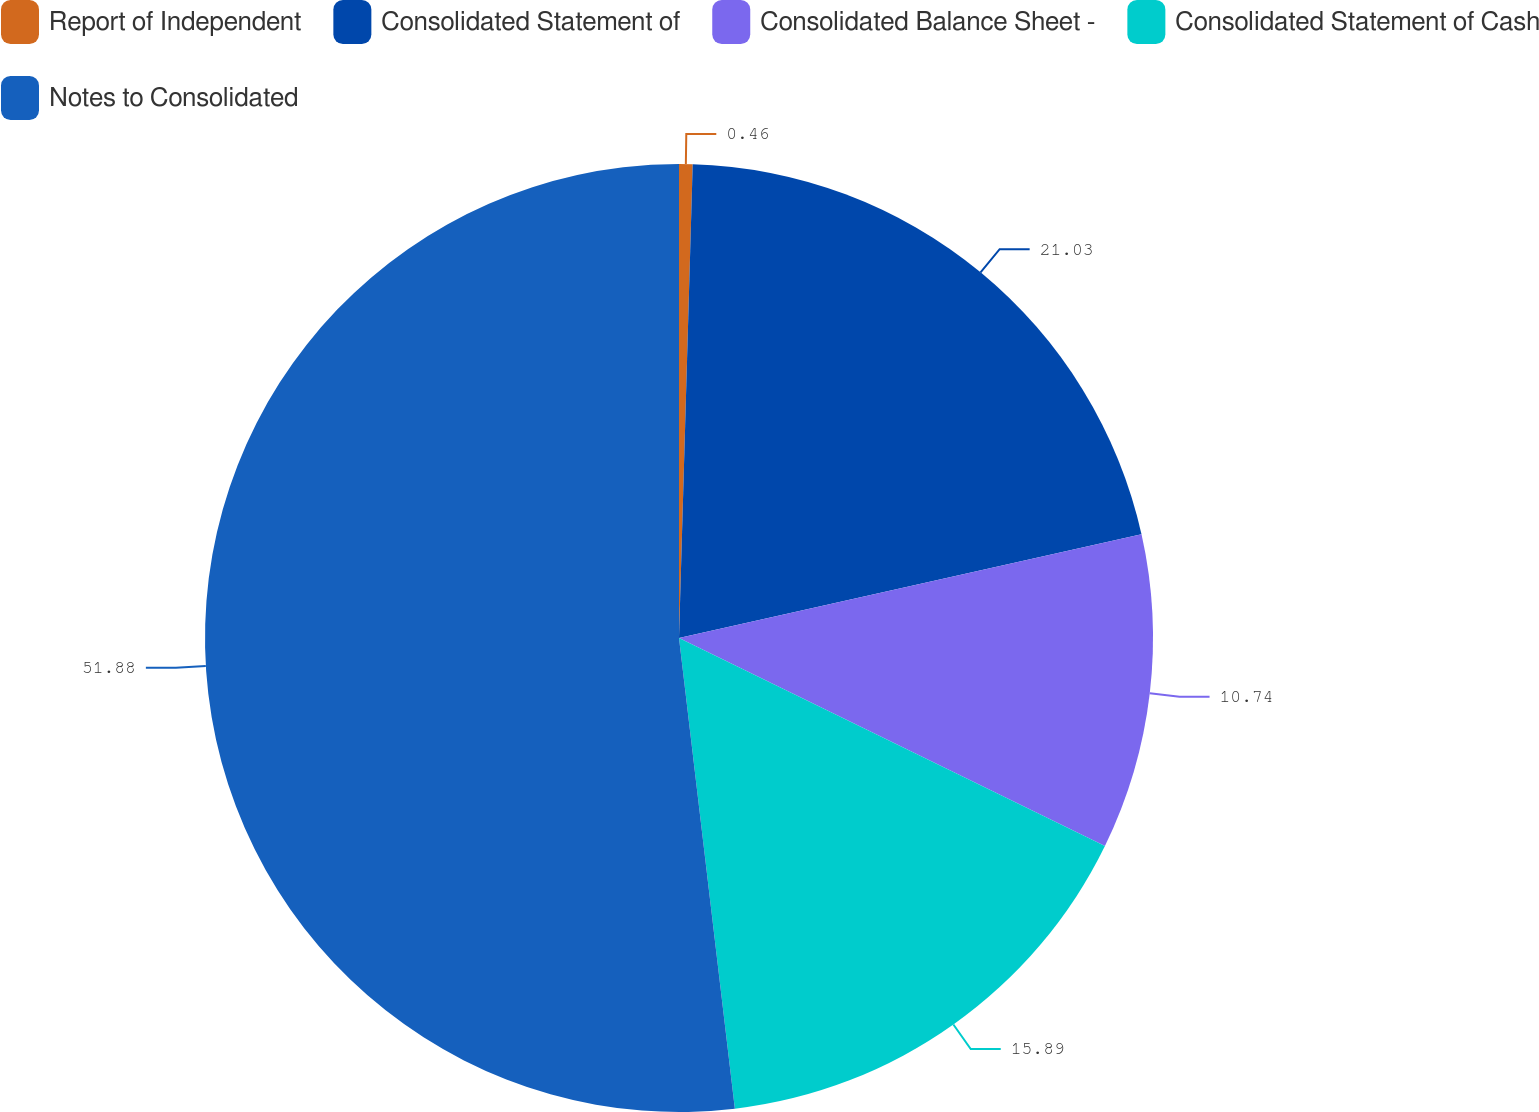Convert chart. <chart><loc_0><loc_0><loc_500><loc_500><pie_chart><fcel>Report of Independent<fcel>Consolidated Statement of<fcel>Consolidated Balance Sheet -<fcel>Consolidated Statement of Cash<fcel>Notes to Consolidated<nl><fcel>0.46%<fcel>21.03%<fcel>10.74%<fcel>15.89%<fcel>51.88%<nl></chart> 